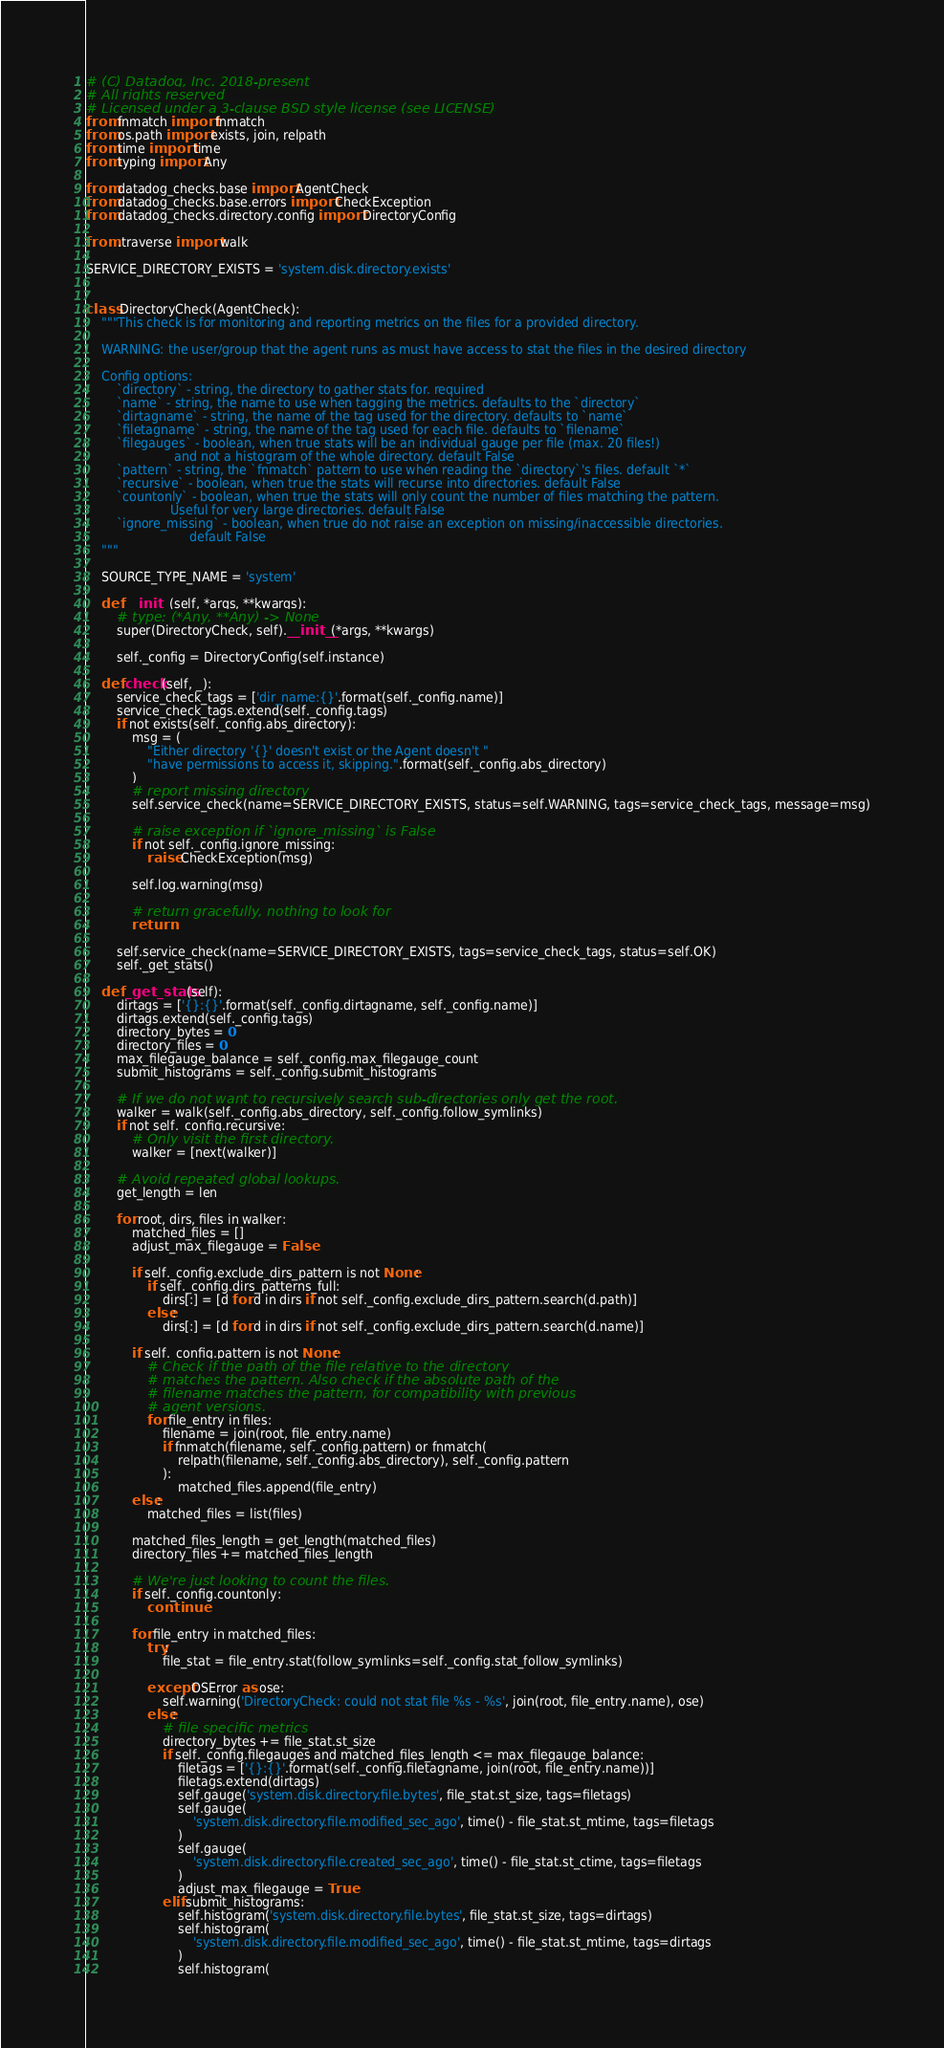<code> <loc_0><loc_0><loc_500><loc_500><_Python_># (C) Datadog, Inc. 2018-present
# All rights reserved
# Licensed under a 3-clause BSD style license (see LICENSE)
from fnmatch import fnmatch
from os.path import exists, join, relpath
from time import time
from typing import Any

from datadog_checks.base import AgentCheck
from datadog_checks.base.errors import CheckException
from datadog_checks.directory.config import DirectoryConfig

from .traverse import walk

SERVICE_DIRECTORY_EXISTS = 'system.disk.directory.exists'


class DirectoryCheck(AgentCheck):
    """This check is for monitoring and reporting metrics on the files for a provided directory.

    WARNING: the user/group that the agent runs as must have access to stat the files in the desired directory

    Config options:
        `directory` - string, the directory to gather stats for. required
        `name` - string, the name to use when tagging the metrics. defaults to the `directory`
        `dirtagname` - string, the name of the tag used for the directory. defaults to `name`
        `filetagname` - string, the name of the tag used for each file. defaults to `filename`
        `filegauges` - boolean, when true stats will be an individual gauge per file (max. 20 files!)
                       and not a histogram of the whole directory. default False
        `pattern` - string, the `fnmatch` pattern to use when reading the `directory`'s files. default `*`
        `recursive` - boolean, when true the stats will recurse into directories. default False
        `countonly` - boolean, when true the stats will only count the number of files matching the pattern.
                      Useful for very large directories. default False
        `ignore_missing` - boolean, when true do not raise an exception on missing/inaccessible directories.
                           default False
    """

    SOURCE_TYPE_NAME = 'system'

    def __init__(self, *args, **kwargs):
        # type: (*Any, **Any) -> None
        super(DirectoryCheck, self).__init__(*args, **kwargs)

        self._config = DirectoryConfig(self.instance)

    def check(self, _):
        service_check_tags = ['dir_name:{}'.format(self._config.name)]
        service_check_tags.extend(self._config.tags)
        if not exists(self._config.abs_directory):
            msg = (
                "Either directory '{}' doesn't exist or the Agent doesn't "
                "have permissions to access it, skipping.".format(self._config.abs_directory)
            )
            # report missing directory
            self.service_check(name=SERVICE_DIRECTORY_EXISTS, status=self.WARNING, tags=service_check_tags, message=msg)

            # raise exception if `ignore_missing` is False
            if not self._config.ignore_missing:
                raise CheckException(msg)

            self.log.warning(msg)

            # return gracefully, nothing to look for
            return

        self.service_check(name=SERVICE_DIRECTORY_EXISTS, tags=service_check_tags, status=self.OK)
        self._get_stats()

    def _get_stats(self):
        dirtags = ['{}:{}'.format(self._config.dirtagname, self._config.name)]
        dirtags.extend(self._config.tags)
        directory_bytes = 0
        directory_files = 0
        max_filegauge_balance = self._config.max_filegauge_count
        submit_histograms = self._config.submit_histograms

        # If we do not want to recursively search sub-directories only get the root.
        walker = walk(self._config.abs_directory, self._config.follow_symlinks)
        if not self._config.recursive:
            # Only visit the first directory.
            walker = [next(walker)]

        # Avoid repeated global lookups.
        get_length = len

        for root, dirs, files in walker:
            matched_files = []
            adjust_max_filegauge = False

            if self._config.exclude_dirs_pattern is not None:
                if self._config.dirs_patterns_full:
                    dirs[:] = [d for d in dirs if not self._config.exclude_dirs_pattern.search(d.path)]
                else:
                    dirs[:] = [d for d in dirs if not self._config.exclude_dirs_pattern.search(d.name)]

            if self._config.pattern is not None:
                # Check if the path of the file relative to the directory
                # matches the pattern. Also check if the absolute path of the
                # filename matches the pattern, for compatibility with previous
                # agent versions.
                for file_entry in files:
                    filename = join(root, file_entry.name)
                    if fnmatch(filename, self._config.pattern) or fnmatch(
                        relpath(filename, self._config.abs_directory), self._config.pattern
                    ):
                        matched_files.append(file_entry)
            else:
                matched_files = list(files)

            matched_files_length = get_length(matched_files)
            directory_files += matched_files_length

            # We're just looking to count the files.
            if self._config.countonly:
                continue

            for file_entry in matched_files:
                try:
                    file_stat = file_entry.stat(follow_symlinks=self._config.stat_follow_symlinks)

                except OSError as ose:
                    self.warning('DirectoryCheck: could not stat file %s - %s', join(root, file_entry.name), ose)
                else:
                    # file specific metrics
                    directory_bytes += file_stat.st_size
                    if self._config.filegauges and matched_files_length <= max_filegauge_balance:
                        filetags = ['{}:{}'.format(self._config.filetagname, join(root, file_entry.name))]
                        filetags.extend(dirtags)
                        self.gauge('system.disk.directory.file.bytes', file_stat.st_size, tags=filetags)
                        self.gauge(
                            'system.disk.directory.file.modified_sec_ago', time() - file_stat.st_mtime, tags=filetags
                        )
                        self.gauge(
                            'system.disk.directory.file.created_sec_ago', time() - file_stat.st_ctime, tags=filetags
                        )
                        adjust_max_filegauge = True
                    elif submit_histograms:
                        self.histogram('system.disk.directory.file.bytes', file_stat.st_size, tags=dirtags)
                        self.histogram(
                            'system.disk.directory.file.modified_sec_ago', time() - file_stat.st_mtime, tags=dirtags
                        )
                        self.histogram(</code> 